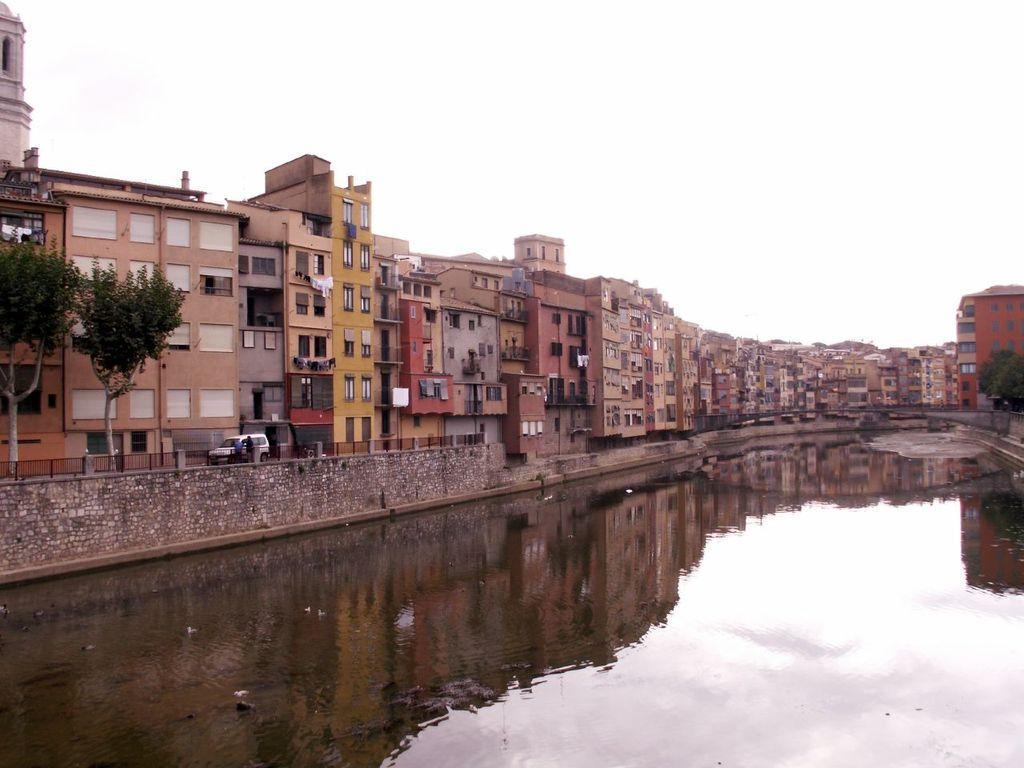In one or two sentences, can you explain what this image depicts? In the center of the image we can see buildings, windows, clothes, trees, bridge, truck, persons are there. At the bottom of the image we can see the water. At the top of the image we can see the sky. 